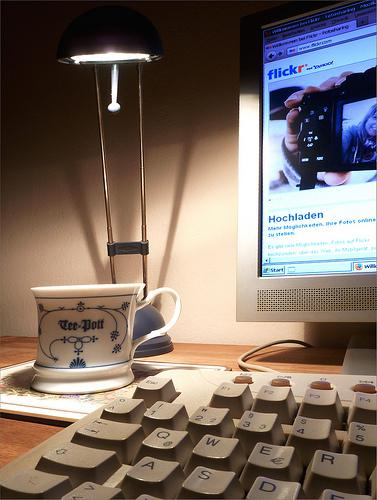Question: what object is foremost in the picture?
Choices:
A. A drum.
B. A keyboard.
C. A guitar.
D. A violin.
Answer with the letter. Answer: B Question: what is to the right of picture?
Choices:
A. A printer.
B. A copy machine.
C. A typewriter.
D. A computer monitor.
Answer with the letter. Answer: D Question: what is under lamp?
Choices:
A. A mug.
B. A pen.
C. A plate.
D. A pencil.
Answer with the letter. Answer: A Question: why is the reading lamp on?
Choices:
A. To read book.
B. Room is dark.
C. To see.
D. To sew.
Answer with the letter. Answer: B Question: what is all the objects sitting on?
Choices:
A. Tables.
B. Counter.
C. Floor.
D. Desk.
Answer with the letter. Answer: D Question: where is the picture taken?
Choices:
A. In a school room.
B. At a hospital.
C. On a home office desk.
D. On a golf course.
Answer with the letter. Answer: C 